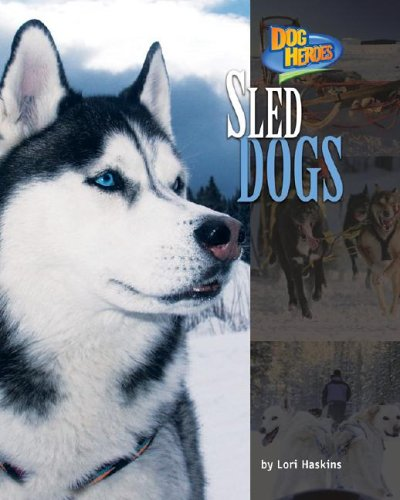What age group is this book intended for? The book 'Sled Dogs' is designed for children, likely targeting the age range of 6–12 years old, to inspire and educate them about sled dogs and their heroics. 